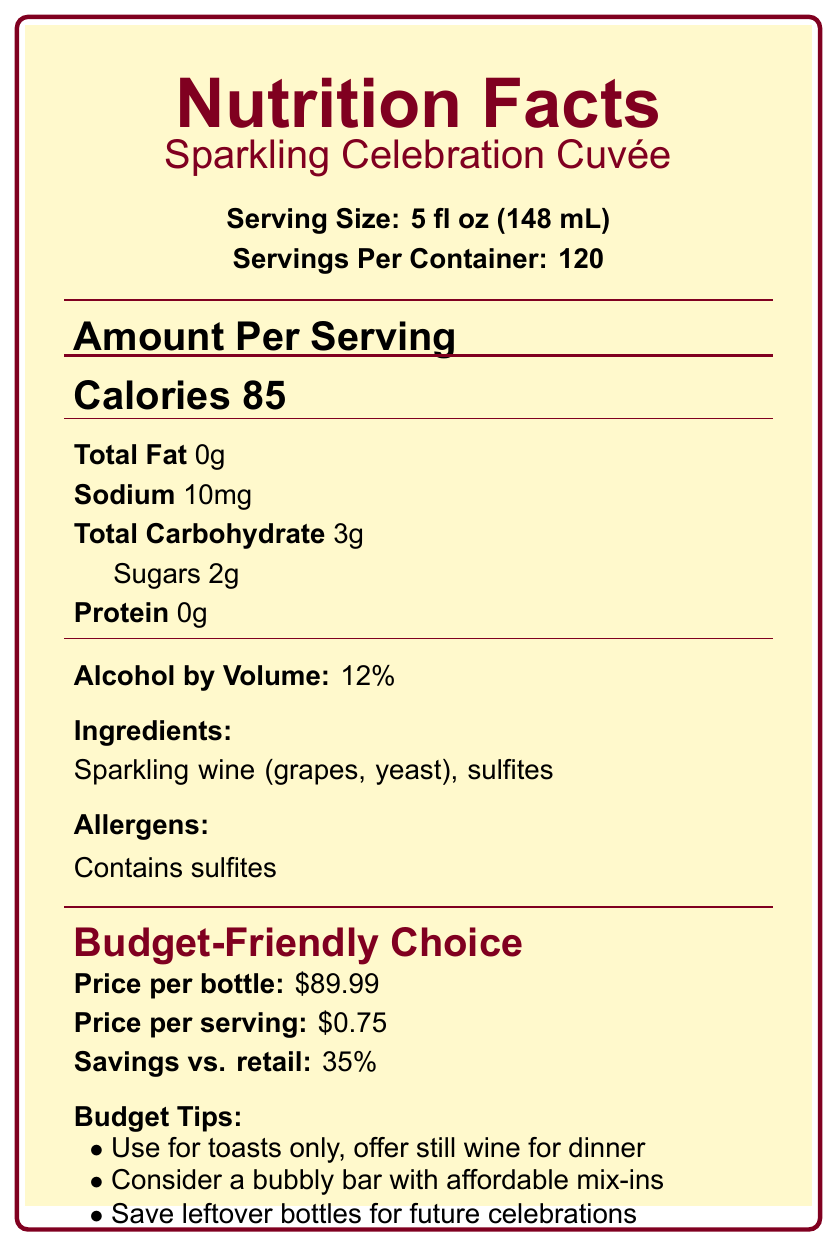what is the price per bottle? The price per bottle is clearly mentioned in the price information section of the document.
Answer: $89.99 how many servings are there in a container? The servings per container are listed in the serving information section of the document.
Answer: 120 how many calories are in one serving? The document lists the calories per serving in the main content area.
Answer: 85 what is the serving size? The serving size is specified in the serving information section.
Answer: 5 fl oz (148 mL) what are the ingredients of the beverage? The ingredients are listed in the ingredients section of the document.
Answer: Sparkling wine (grapes, yeast), sulfites Does the beverage contain any allergens? The beverage contains sulfites, as listed in the allergens section.
Answer: Yes what is the alcohol by volume percentage? The alcohol by volume percentage is mentioned in the main content section.
Answer: 12% what is the main advantage of buying in bulk? A. Higher price per serving B. More convenient for large gatherings C. Increased packaging waste D. Limited toasts The bulk purchase benefits section lists "Convenient for large gatherings" as an advantage.
Answer: B which of the following is NOT a pairing recommendation? A. Light appetizers B. Seafood dishes C. Fresh fruit D. Red meat Red meat is not listed in the pairing recommendations section, whereas A, B, and C are.
Answer: D Does the document suggest any budget tips for using the beverage? The document provides budget tips under the budget tips section, such as using for toasts only.
Answer: Yes is there a savings compared to retail price? The document mentions a 35% savings compared to retail price in the price information section.
Answer: Yes what should be done with leftover bottles? One of the budget tips listed is to save leftover bottles for future celebrations.
Answer: Save for future celebrations summarize the main content of the document. The main idea of the document is to give a comprehensive overview of the nutritional and financial aspects of the Sparkling Celebration Cuvée, making it easier for consumers to make an informed purchase for large gatherings such as weddings.
Answer: The document provides detailed nutrition facts and budget information for the Sparkling Celebration Cuvée, including serving size, calorie count, price per bottle and per serving, ingredients, and several budget tips and pairing recommendations. how many grams of total fat are in one serving of the beverage? The total fat per serving is listed as 0g in the main content section of the document.
Answer: 0g what is the sodium content per serving? The sodium content per serving is listed in the main content section of the document.
Answer: 10mg Can I find the exact vineyard where the grapes are grown? The document lists the ingredients and the manufacturer but does not provide information about the exact vineyard where the grapes are grown.
Answer: Cannot be determined 